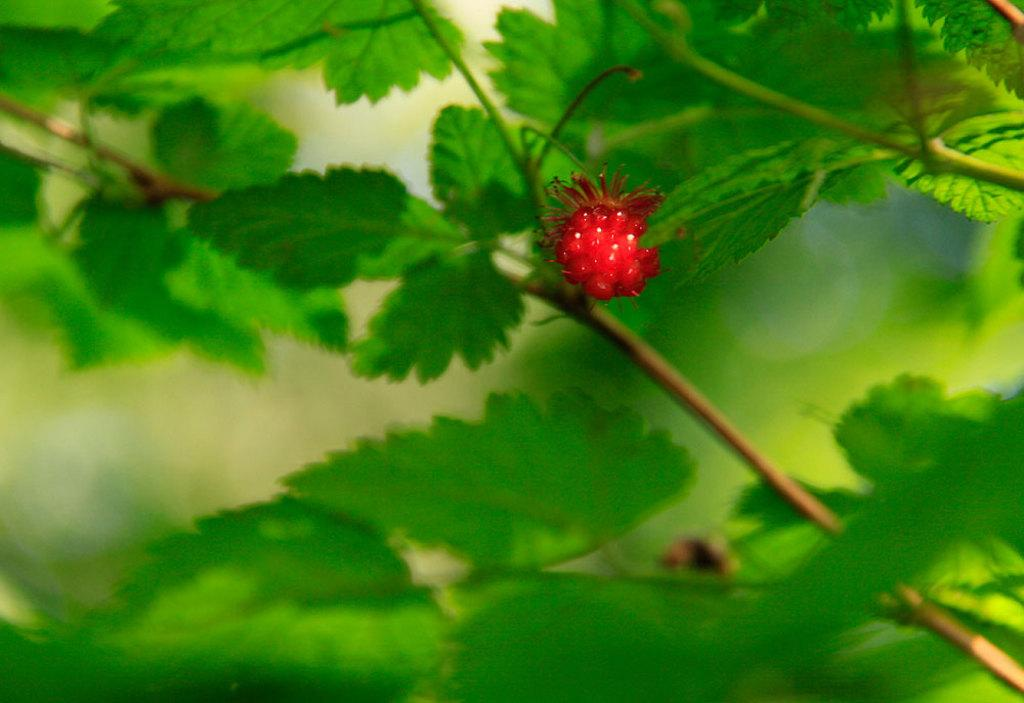What type of vegetation can be seen in the image? There are leaves in the image. What else can be found among the leaves in the image? There are fruits in the image. Can you describe the background of the image? The background of the image is blurry. How does the earthquake affect the fruits in the image? There is no earthquake present in the image, so its effects cannot be determined. 